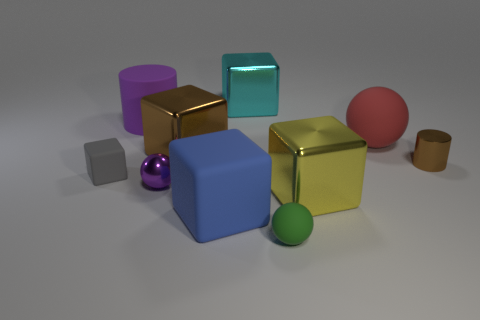Is there any other thing that has the same shape as the yellow shiny thing?
Make the answer very short. Yes. What is the color of the tiny sphere right of the big block that is behind the red rubber sphere?
Give a very brief answer. Green. How many big green things are there?
Offer a very short reply. 0. How many rubber things are red things or brown things?
Offer a terse response. 1. How many big things have the same color as the large matte cube?
Your answer should be very brief. 0. There is a brown thing that is behind the brown thing right of the cyan cube; what is its material?
Offer a very short reply. Metal. What size is the purple matte cylinder?
Your response must be concise. Large. How many cyan metal things have the same size as the green matte object?
Offer a terse response. 0. How many tiny shiny objects are the same shape as the large yellow object?
Your answer should be compact. 0. Is the number of large rubber cylinders in front of the big purple matte cylinder the same as the number of big cyan metallic blocks?
Your response must be concise. No. 